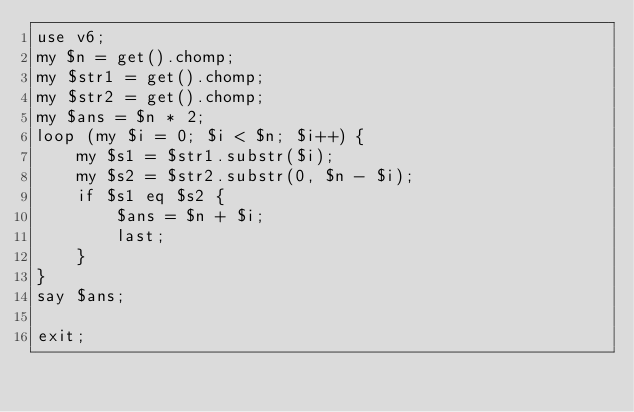<code> <loc_0><loc_0><loc_500><loc_500><_Perl_>use v6;
my $n = get().chomp;
my $str1 = get().chomp;
my $str2 = get().chomp;
my $ans = $n * 2;
loop (my $i = 0; $i < $n; $i++) {
	my $s1 = $str1.substr($i);
	my $s2 = $str2.substr(0, $n - $i);
	if $s1 eq $s2 {
		$ans = $n + $i;
		last;
	}
}
say $ans;

exit;</code> 